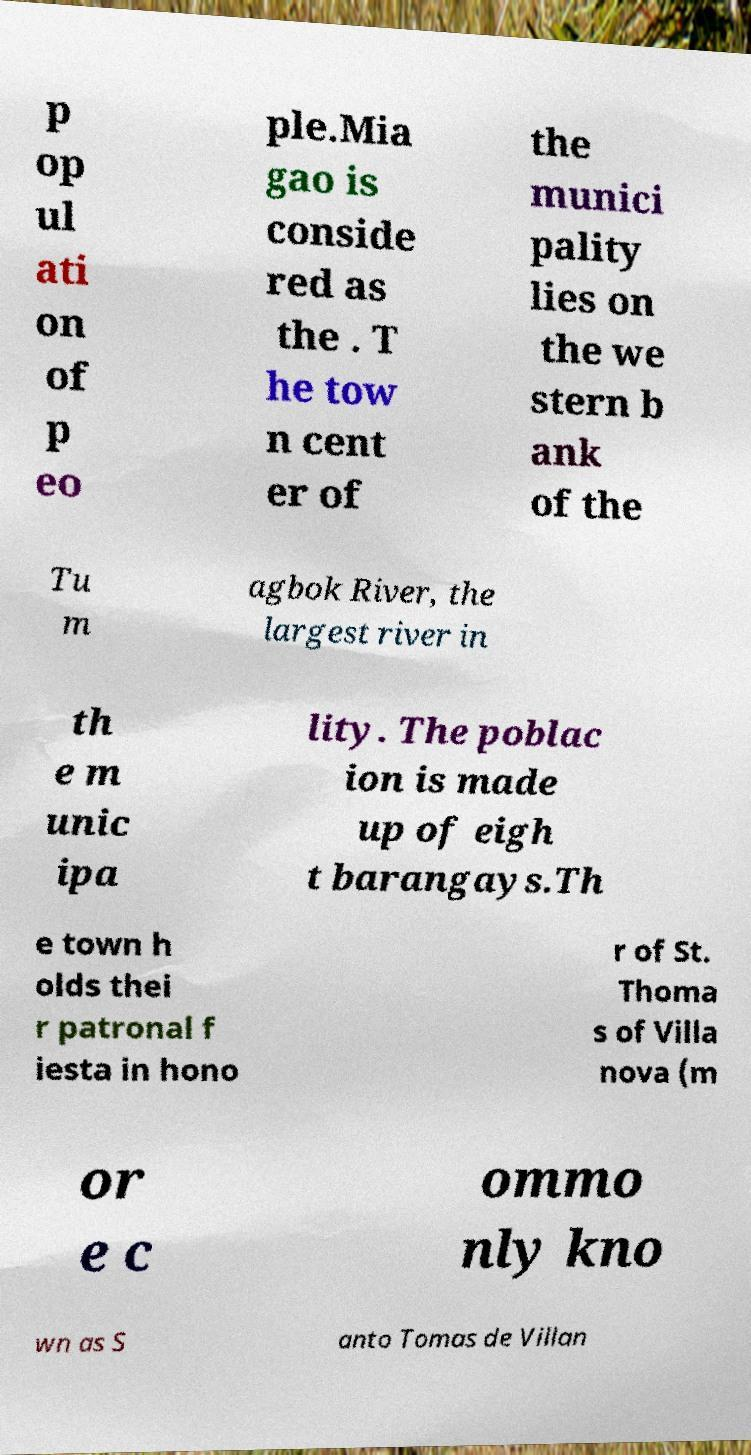Can you accurately transcribe the text from the provided image for me? p op ul ati on of p eo ple.Mia gao is conside red as the . T he tow n cent er of the munici pality lies on the we stern b ank of the Tu m agbok River, the largest river in th e m unic ipa lity. The poblac ion is made up of eigh t barangays.Th e town h olds thei r patronal f iesta in hono r of St. Thoma s of Villa nova (m or e c ommo nly kno wn as S anto Tomas de Villan 